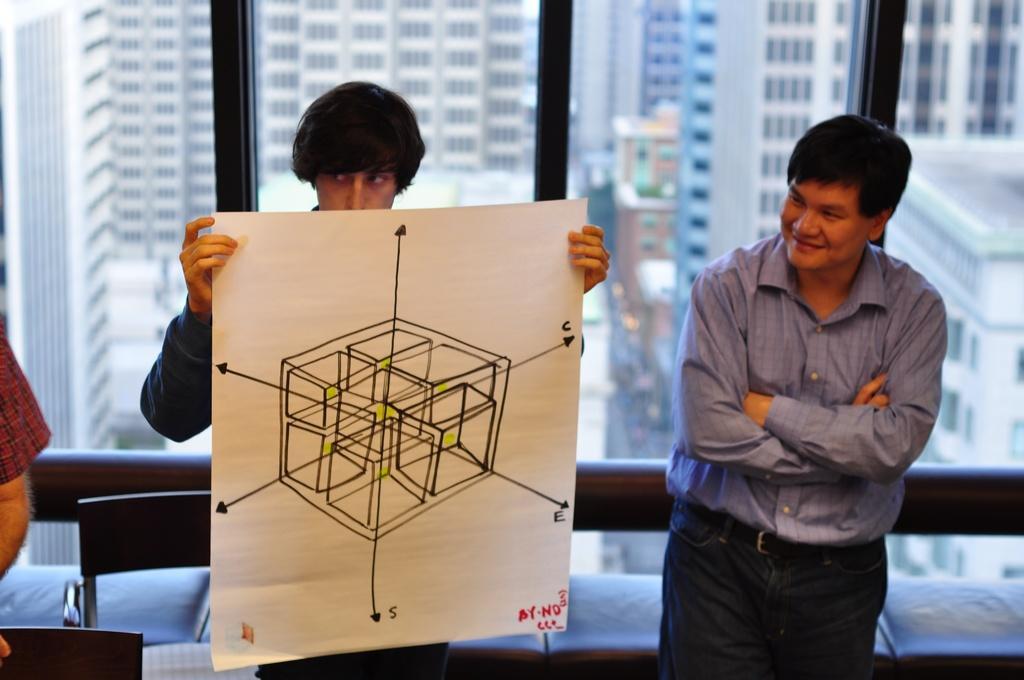How would you summarize this image in a sentence or two? In this image I see 3 persons , in which one of them is smiling and another one is holding the paper. In the background I see lot of buildings and the window. 